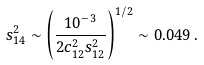<formula> <loc_0><loc_0><loc_500><loc_500>s ^ { 2 } _ { 1 4 } \sim \left ( \frac { 1 0 ^ { - 3 } } { 2 c ^ { 2 } _ { 1 2 } s ^ { 2 } _ { 1 2 } } \right ) ^ { 1 / 2 } \sim 0 . 0 4 9 \, .</formula> 